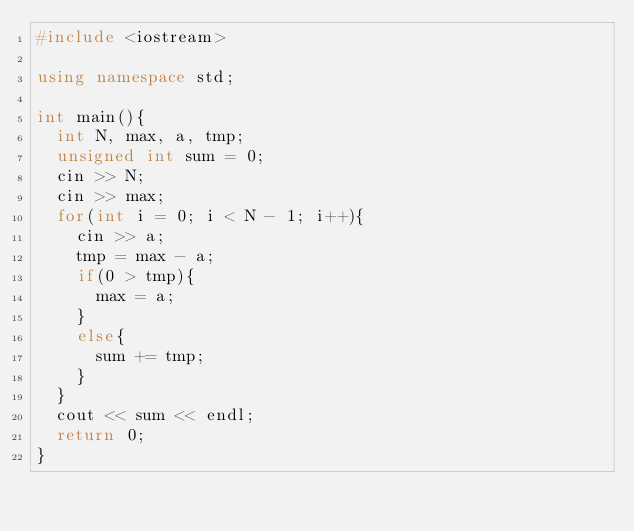Convert code to text. <code><loc_0><loc_0><loc_500><loc_500><_C++_>#include <iostream>

using namespace std;

int main(){
  int N, max, a, tmp;
  unsigned int sum = 0;
  cin >> N;
  cin >> max;
  for(int i = 0; i < N - 1; i++){
    cin >> a;
    tmp = max - a;
    if(0 > tmp){
      max = a;
    }
    else{
      sum += tmp;
    }
  }        
  cout << sum << endl;
  return 0;
}</code> 